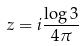Convert formula to latex. <formula><loc_0><loc_0><loc_500><loc_500>z = i \frac { \log 3 } { 4 \pi }</formula> 